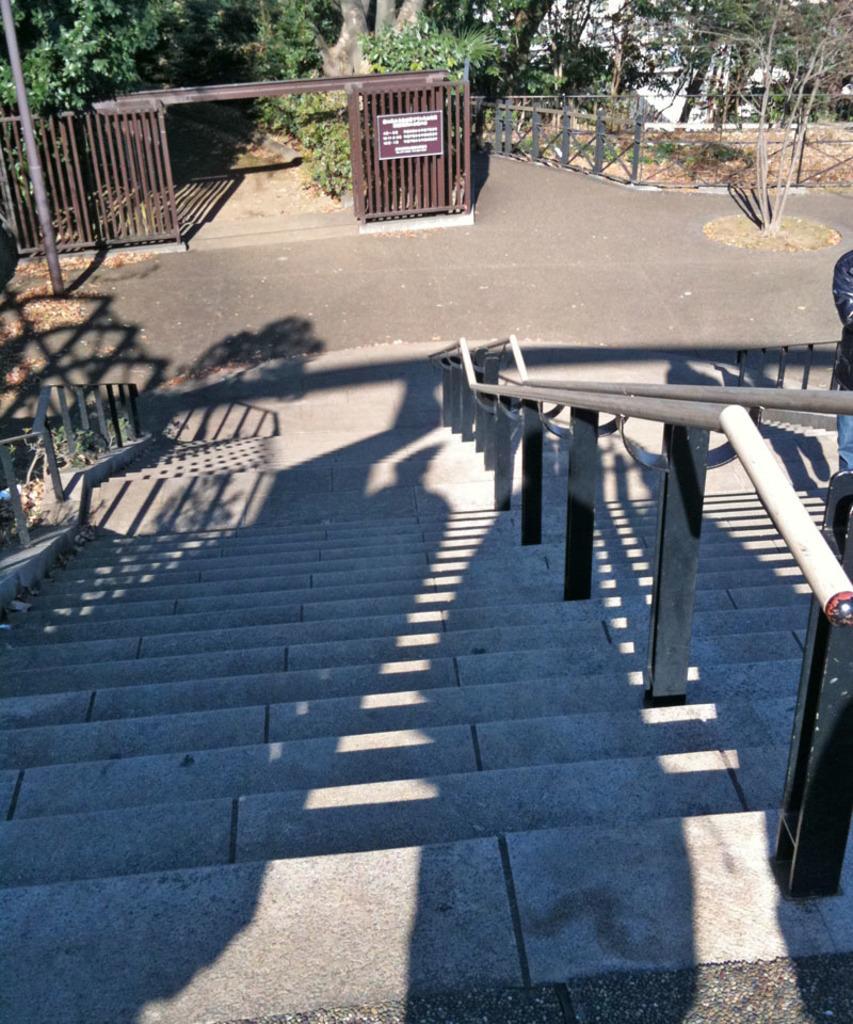In one or two sentences, can you explain what this image depicts? In the foreground, I can see steps and metal rods. In the background, I can see a fence, trees, pole, grass and so on. This picture might be taken in a day. 